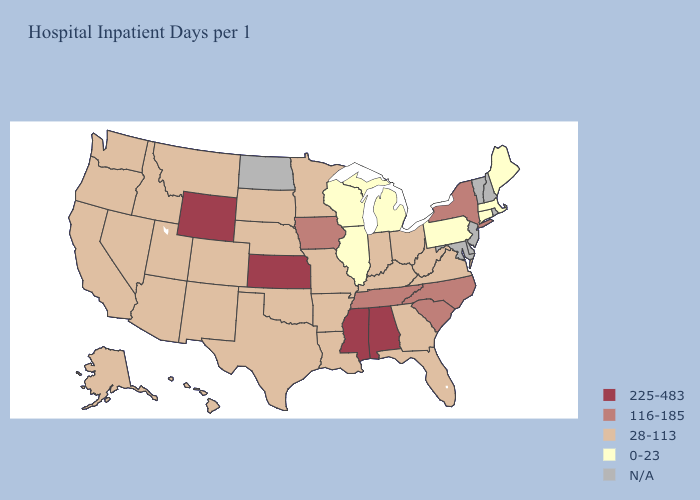Among the states that border Massachusetts , does New York have the lowest value?
Concise answer only. No. Name the states that have a value in the range 116-185?
Be succinct. Iowa, New York, North Carolina, South Carolina, Tennessee. Name the states that have a value in the range 28-113?
Give a very brief answer. Alaska, Arizona, Arkansas, California, Colorado, Florida, Georgia, Hawaii, Idaho, Indiana, Kentucky, Louisiana, Minnesota, Missouri, Montana, Nebraska, Nevada, New Mexico, Ohio, Oklahoma, Oregon, South Dakota, Texas, Utah, Virginia, Washington, West Virginia. What is the value of Connecticut?
Give a very brief answer. 0-23. What is the lowest value in the USA?
Concise answer only. 0-23. What is the value of Montana?
Concise answer only. 28-113. Does Texas have the highest value in the USA?
Write a very short answer. No. Among the states that border Wisconsin , does Minnesota have the highest value?
Be succinct. No. What is the value of West Virginia?
Short answer required. 28-113. Which states have the highest value in the USA?
Answer briefly. Alabama, Kansas, Mississippi, Wyoming. What is the lowest value in states that border Utah?
Be succinct. 28-113. Among the states that border Utah , does Wyoming have the highest value?
Write a very short answer. Yes. What is the value of Nebraska?
Quick response, please. 28-113. Does Nevada have the highest value in the USA?
Give a very brief answer. No. 